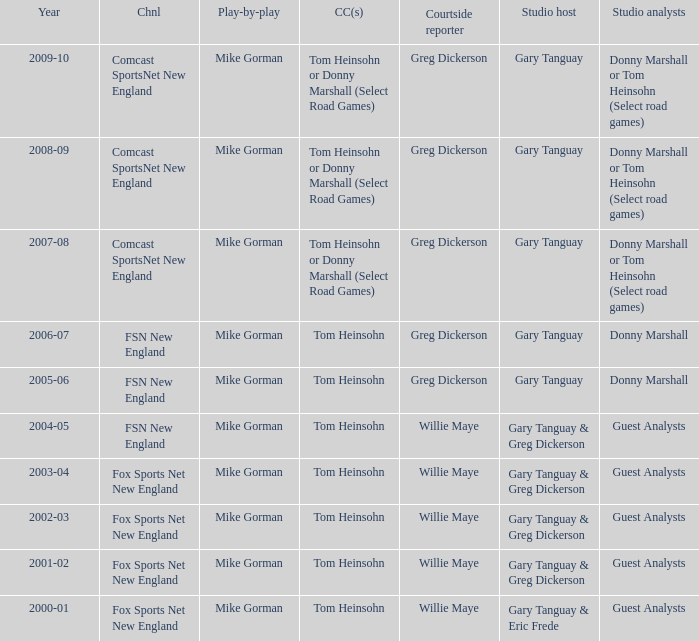WHich Color commentatorhas a Studio host of gary tanguay & eric frede? Tom Heinsohn. 